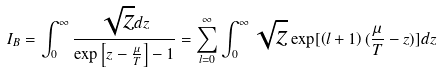Convert formula to latex. <formula><loc_0><loc_0><loc_500><loc_500>I _ { B } = \int _ { 0 } ^ { \infty } \frac { \sqrt { z } d z } { \exp \left [ z - \frac { \mu } { T } \right ] - 1 } = \sum _ { l = 0 } ^ { \infty } \int _ { 0 } ^ { \infty } \sqrt { z } \exp [ \left ( l + 1 \right ) ( \frac { \mu } { T } - z ) ] d z</formula> 